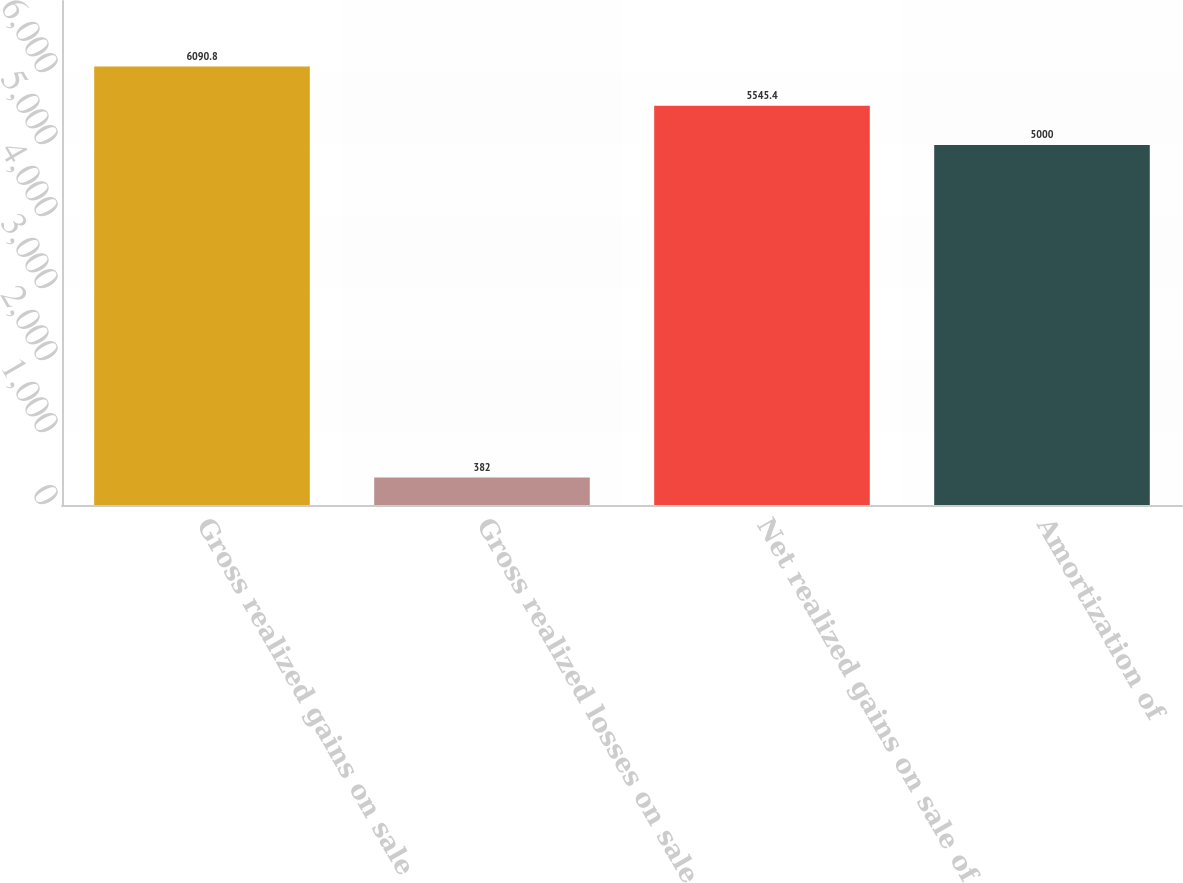Convert chart to OTSL. <chart><loc_0><loc_0><loc_500><loc_500><bar_chart><fcel>Gross realized gains on sale<fcel>Gross realized losses on sale<fcel>Net realized gains on sale of<fcel>Amortization of<nl><fcel>6090.8<fcel>382<fcel>5545.4<fcel>5000<nl></chart> 